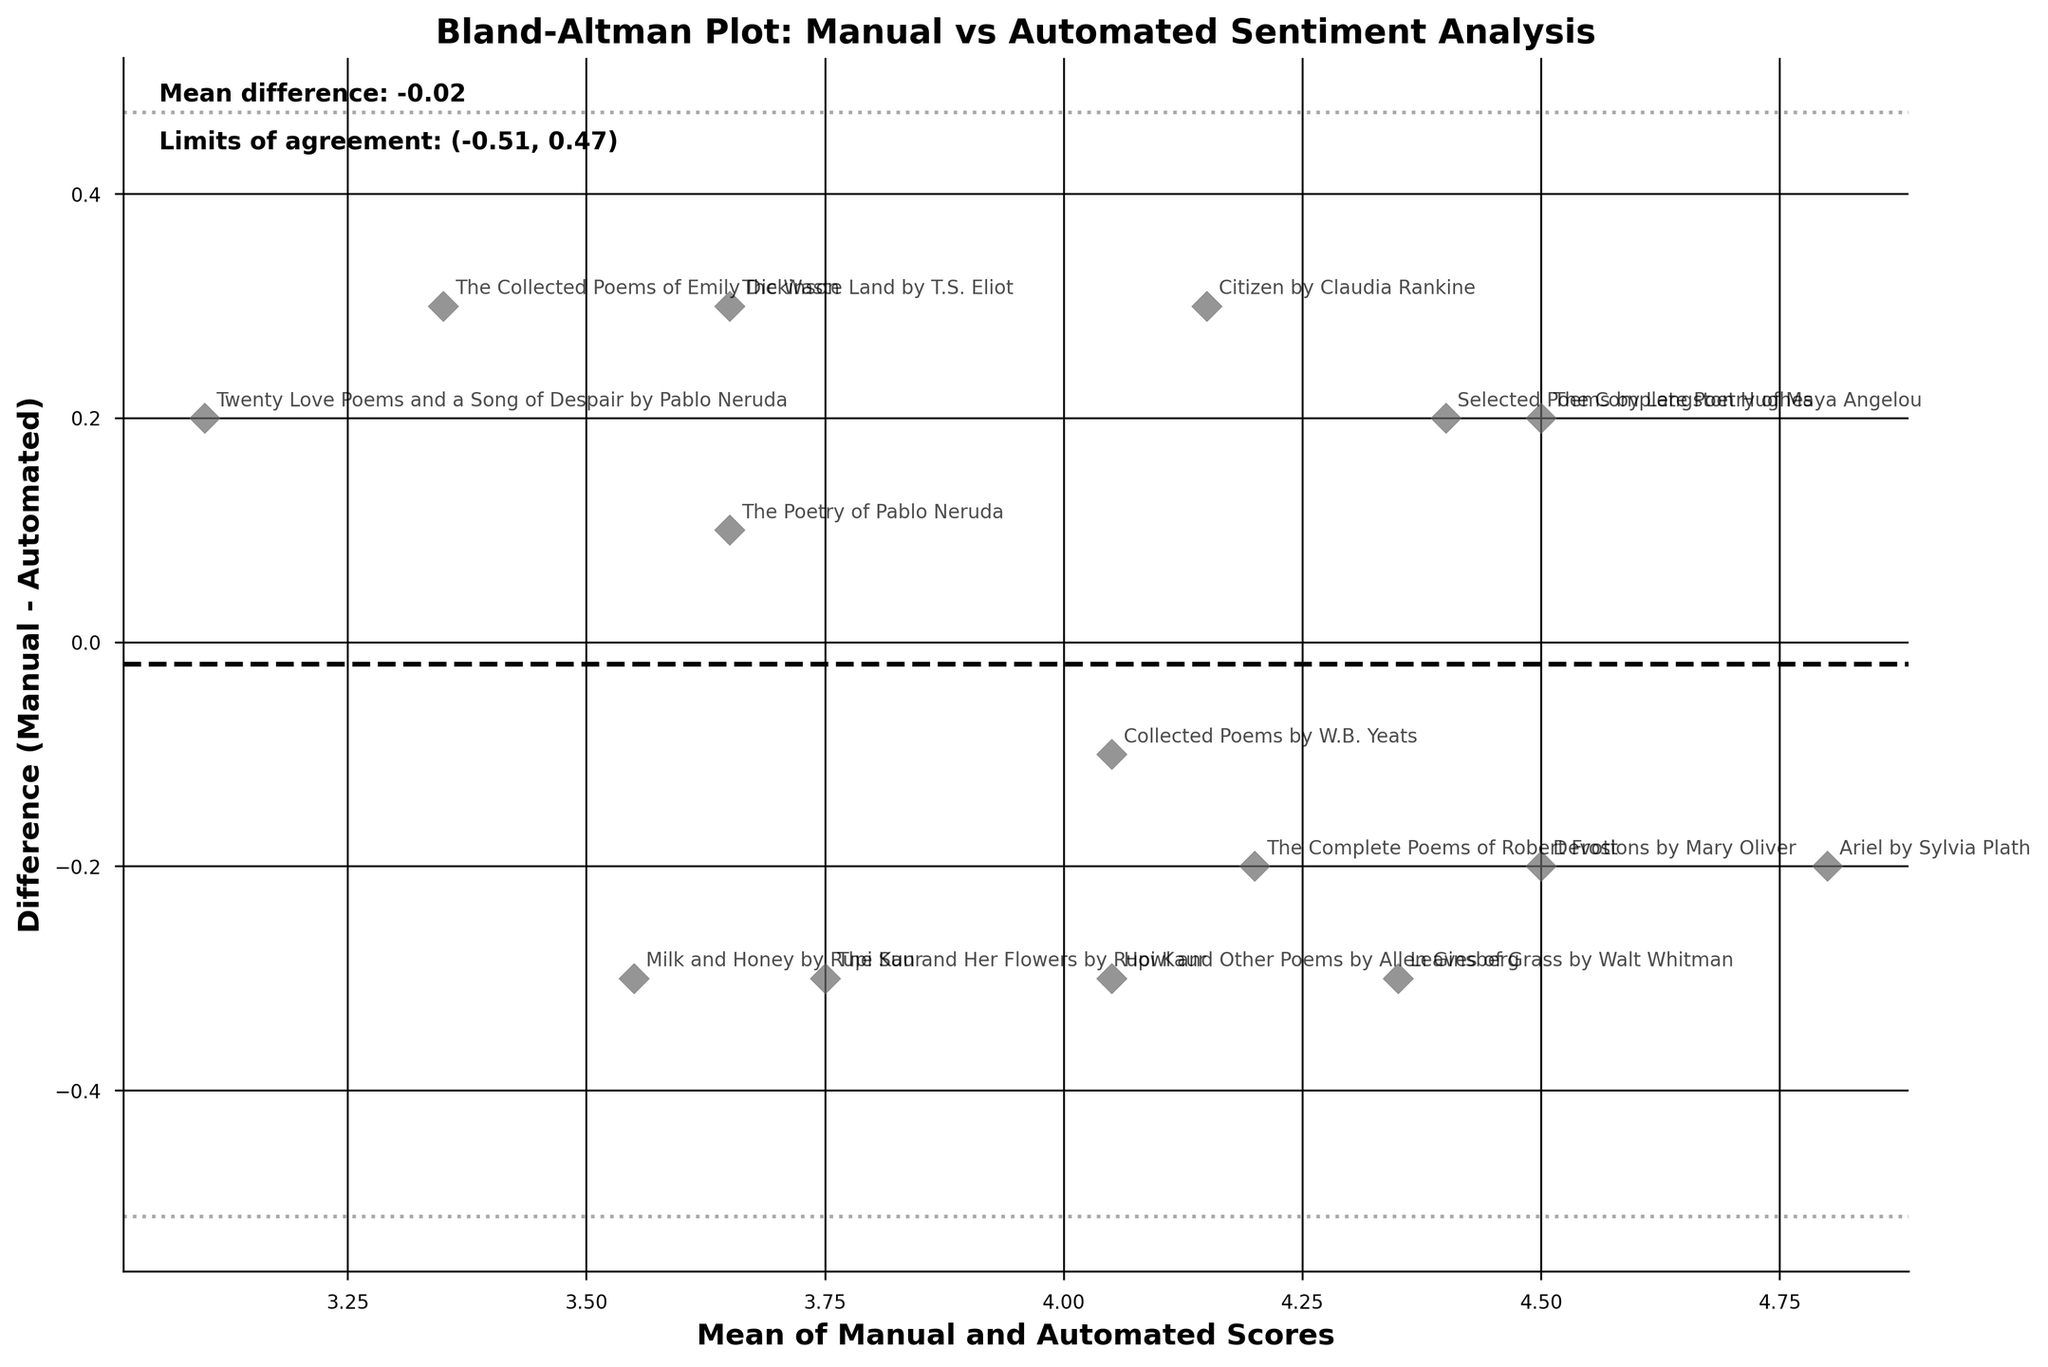What is the title of the plot? The title of a plot is typically found at the top of the figure. In this case, the title is bold and prominent, "Bland-Altman Plot: Manual vs Automated Sentiment Analysis."
Answer: Bland-Altman Plot: Manual vs Automated Sentiment Analysis What are the labels on the axes? Axis labels describe what each axis represents. In this figure, the x-axis is labeled "Mean of Manual and Automated Scores," and the y-axis is labeled "Difference (Manual - Automated)."
Answer: Mean of Manual and Automated Scores and Difference (Manual - Automated) What color are the data points on the plot? The color of the data points is described visually as "dimgray," which is visible as gray with a slightly dark tone.
Answer: Dimgray How many poetry collections are represented in the plot? Each data point represents a poetry collection. Counting the data points in the plot gives the number of collections, which is 15.
Answer: 15 What is the mean difference between the manual and automated scores? The mean difference is marked by a horizontal dashed line in the plot. The text annotation on the plot indicates this mean difference value as approximately 0.04.
Answer: 0.04 What are the limits of agreement for the plot? The limits of agreement are noted by two horizontal dotted lines. The text annotation specifies these two values as approximately -0.37 (lower limit) and 0.45 (upper limit).
Answer: -0.37 and 0.45 Which poetry collection has the largest positive difference between manual and automated scores? By scanning the plot visually for the highest positive difference (the highest point above the mean difference line), this corresponds to "Howl and Other Poems by Allen Ginsberg."
Answer: Howl and Other Poems by Allen Ginsberg Does any data point lie outside the limits of agreement? Observing the plot, if all data points fall within the two horizontal dotted lines representing the limits of agreement, it implies none lie outside these bounds.
Answer: No What is illustrated by the mean of manual and automated scores on the x-axis? The x-axis illustrates the average value of manual and automated sentiment scores for each poetry collection, showing the general trend of scoring.
Answer: The average scores for each collection Why are there annotations next to each data point? Annotations provide the names of the poetry collections associated with each data point, making it easy to identify which collection corresponds to which pair of scores.
Answer: To identify poetry collections What does it signify if a point is far above or below the mean difference line? Points far above or below the mean difference line indicate a significant discrepancy between the manual and automated sentiment analysis scores for that collection.
Answer: Significant discrepancy in scores 